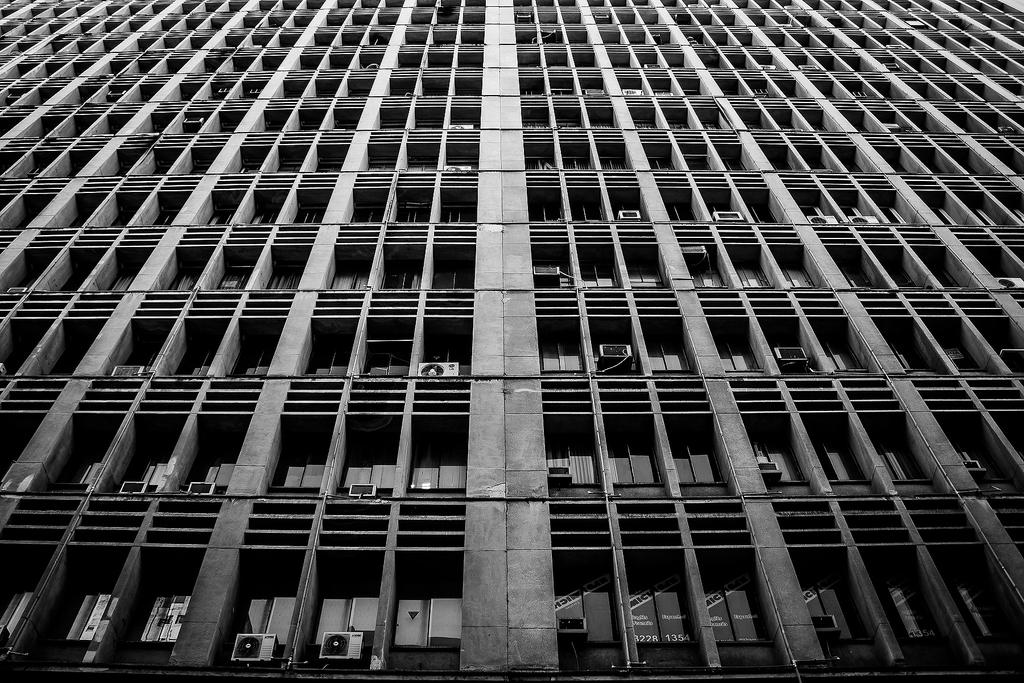What type of structure is present in the image? There is a building in the image. What are some features of the building? The building has windows and air conditioners visible on it. What type of vessel is being used to hammer nails into the building in the image? There is no vessel or hammer present in the image; it only shows a building with windows and air conditioners. 